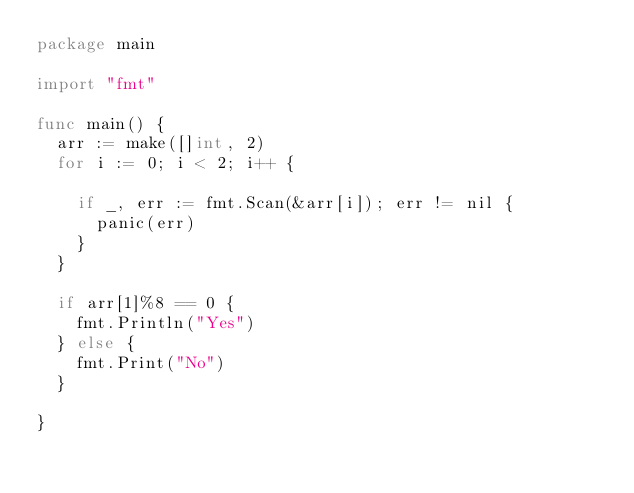Convert code to text. <code><loc_0><loc_0><loc_500><loc_500><_Go_>package main

import "fmt"

func main() {
	arr := make([]int, 2)
	for i := 0; i < 2; i++ {

		if _, err := fmt.Scan(&arr[i]); err != nil {
			panic(err)
		}
	}

	if arr[1]%8 == 0 {
		fmt.Println("Yes")
	} else {
		fmt.Print("No")
	}

}
</code> 